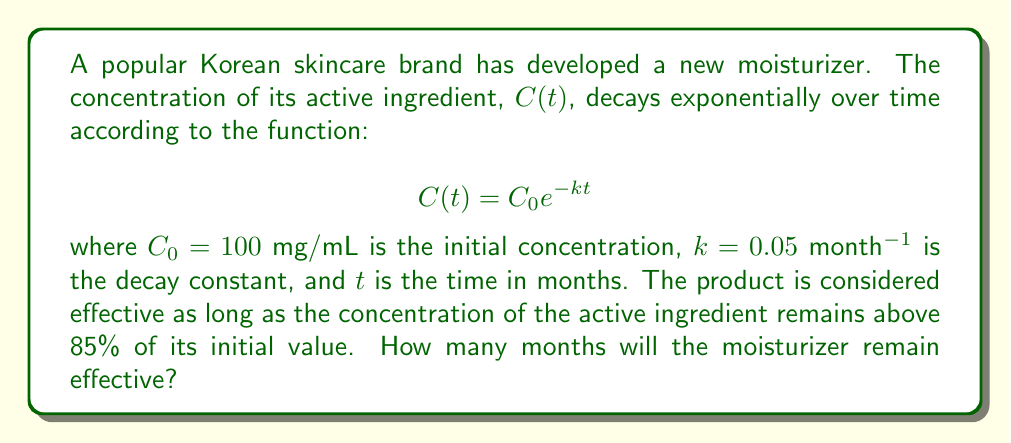Show me your answer to this math problem. To solve this problem, we need to follow these steps:

1) We want to find the time $t$ when the concentration drops to 85% of its initial value. Let's call this concentration $C(t)$:

   $C(t) = 0.85 \cdot C_0 = 0.85 \cdot 100 = 85$ mg/mL

2) Now we can set up our equation:

   $85 = 100 e^{-0.05t}$

3) Divide both sides by 100:

   $0.85 = e^{-0.05t}$

4) Take the natural logarithm of both sides:

   $\ln(0.85) = -0.05t$

5) Solve for $t$:

   $t = -\frac{\ln(0.85)}{0.05}$

6) Calculate the value:

   $t = -\frac{\ln(0.85)}{0.05} \approx 3.25$ months

Therefore, the moisturizer will remain effective for approximately 3.25 months.
Answer: 3.25 months 